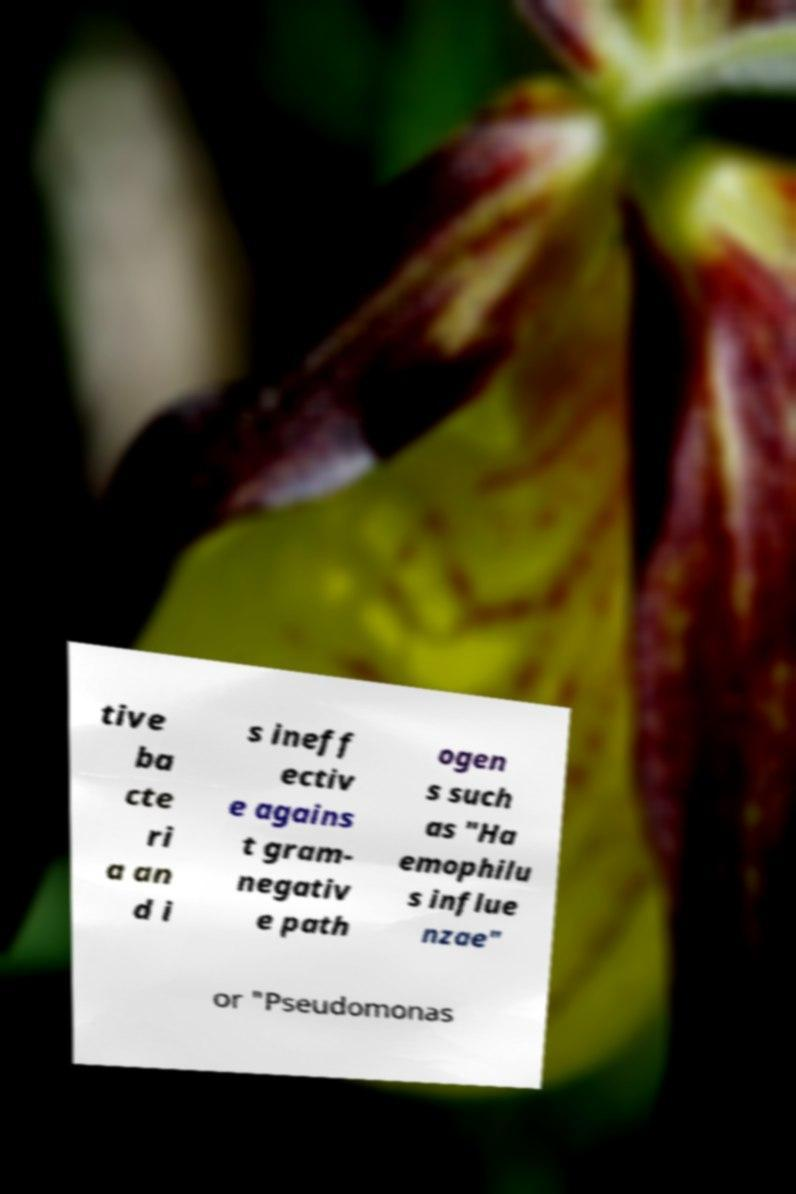Could you extract and type out the text from this image? tive ba cte ri a an d i s ineff ectiv e agains t gram- negativ e path ogen s such as "Ha emophilu s influe nzae" or "Pseudomonas 